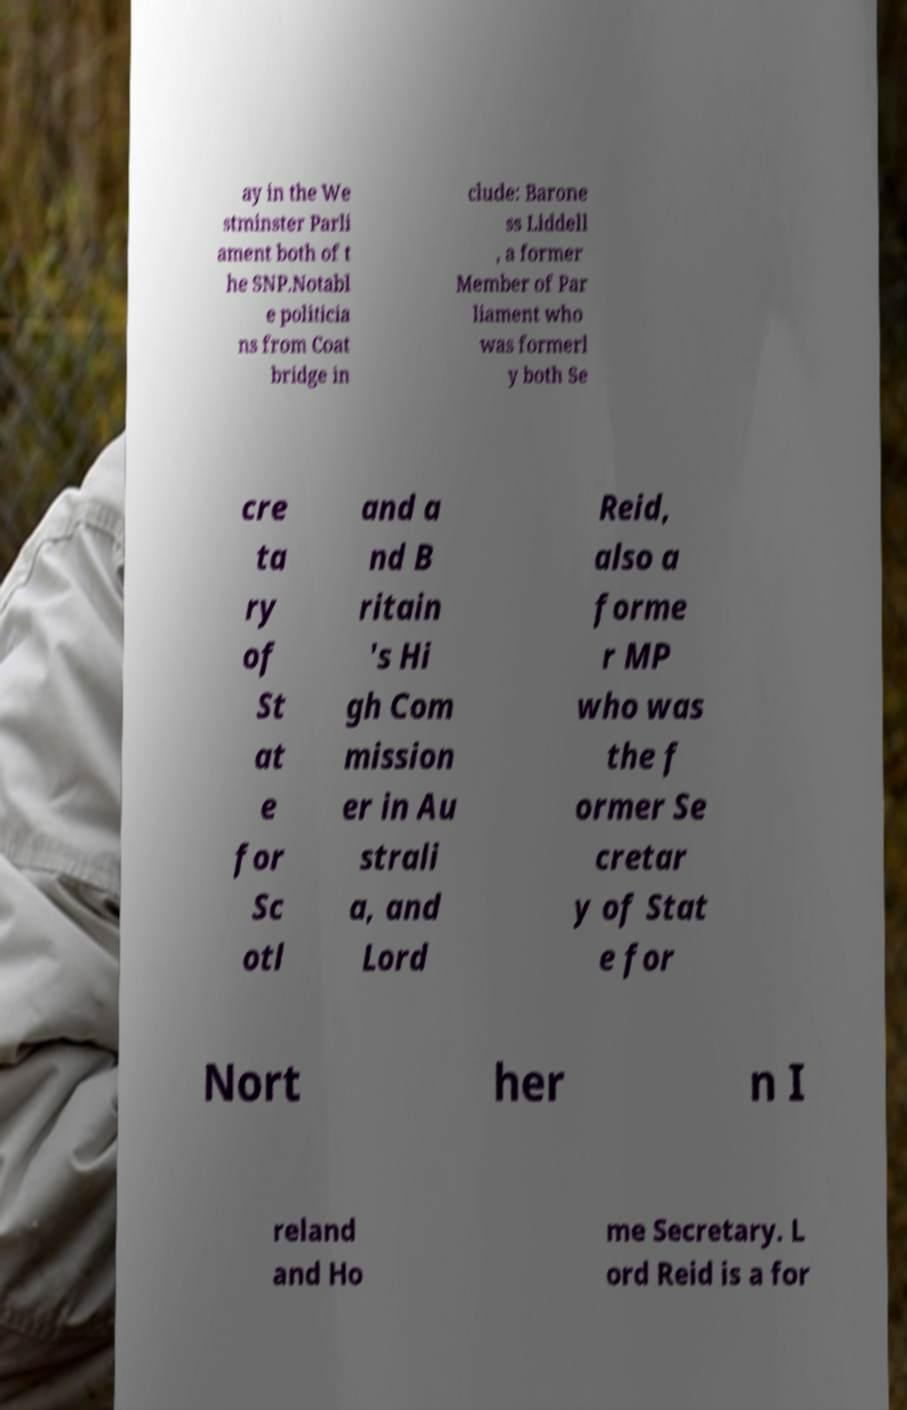Can you read and provide the text displayed in the image?This photo seems to have some interesting text. Can you extract and type it out for me? ay in the We stminster Parli ament both of t he SNP.Notabl e politicia ns from Coat bridge in clude: Barone ss Liddell , a former Member of Par liament who was formerl y both Se cre ta ry of St at e for Sc otl and a nd B ritain 's Hi gh Com mission er in Au strali a, and Lord Reid, also a forme r MP who was the f ormer Se cretar y of Stat e for Nort her n I reland and Ho me Secretary. L ord Reid is a for 